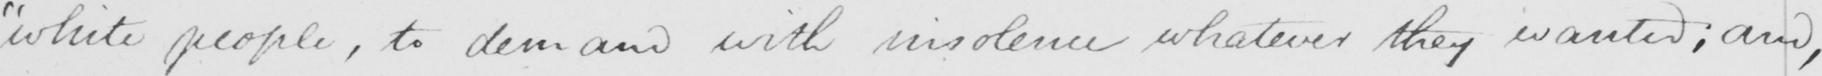Can you read and transcribe this handwriting? " the white people , to demand with insolence whatever they wanted ; and , 